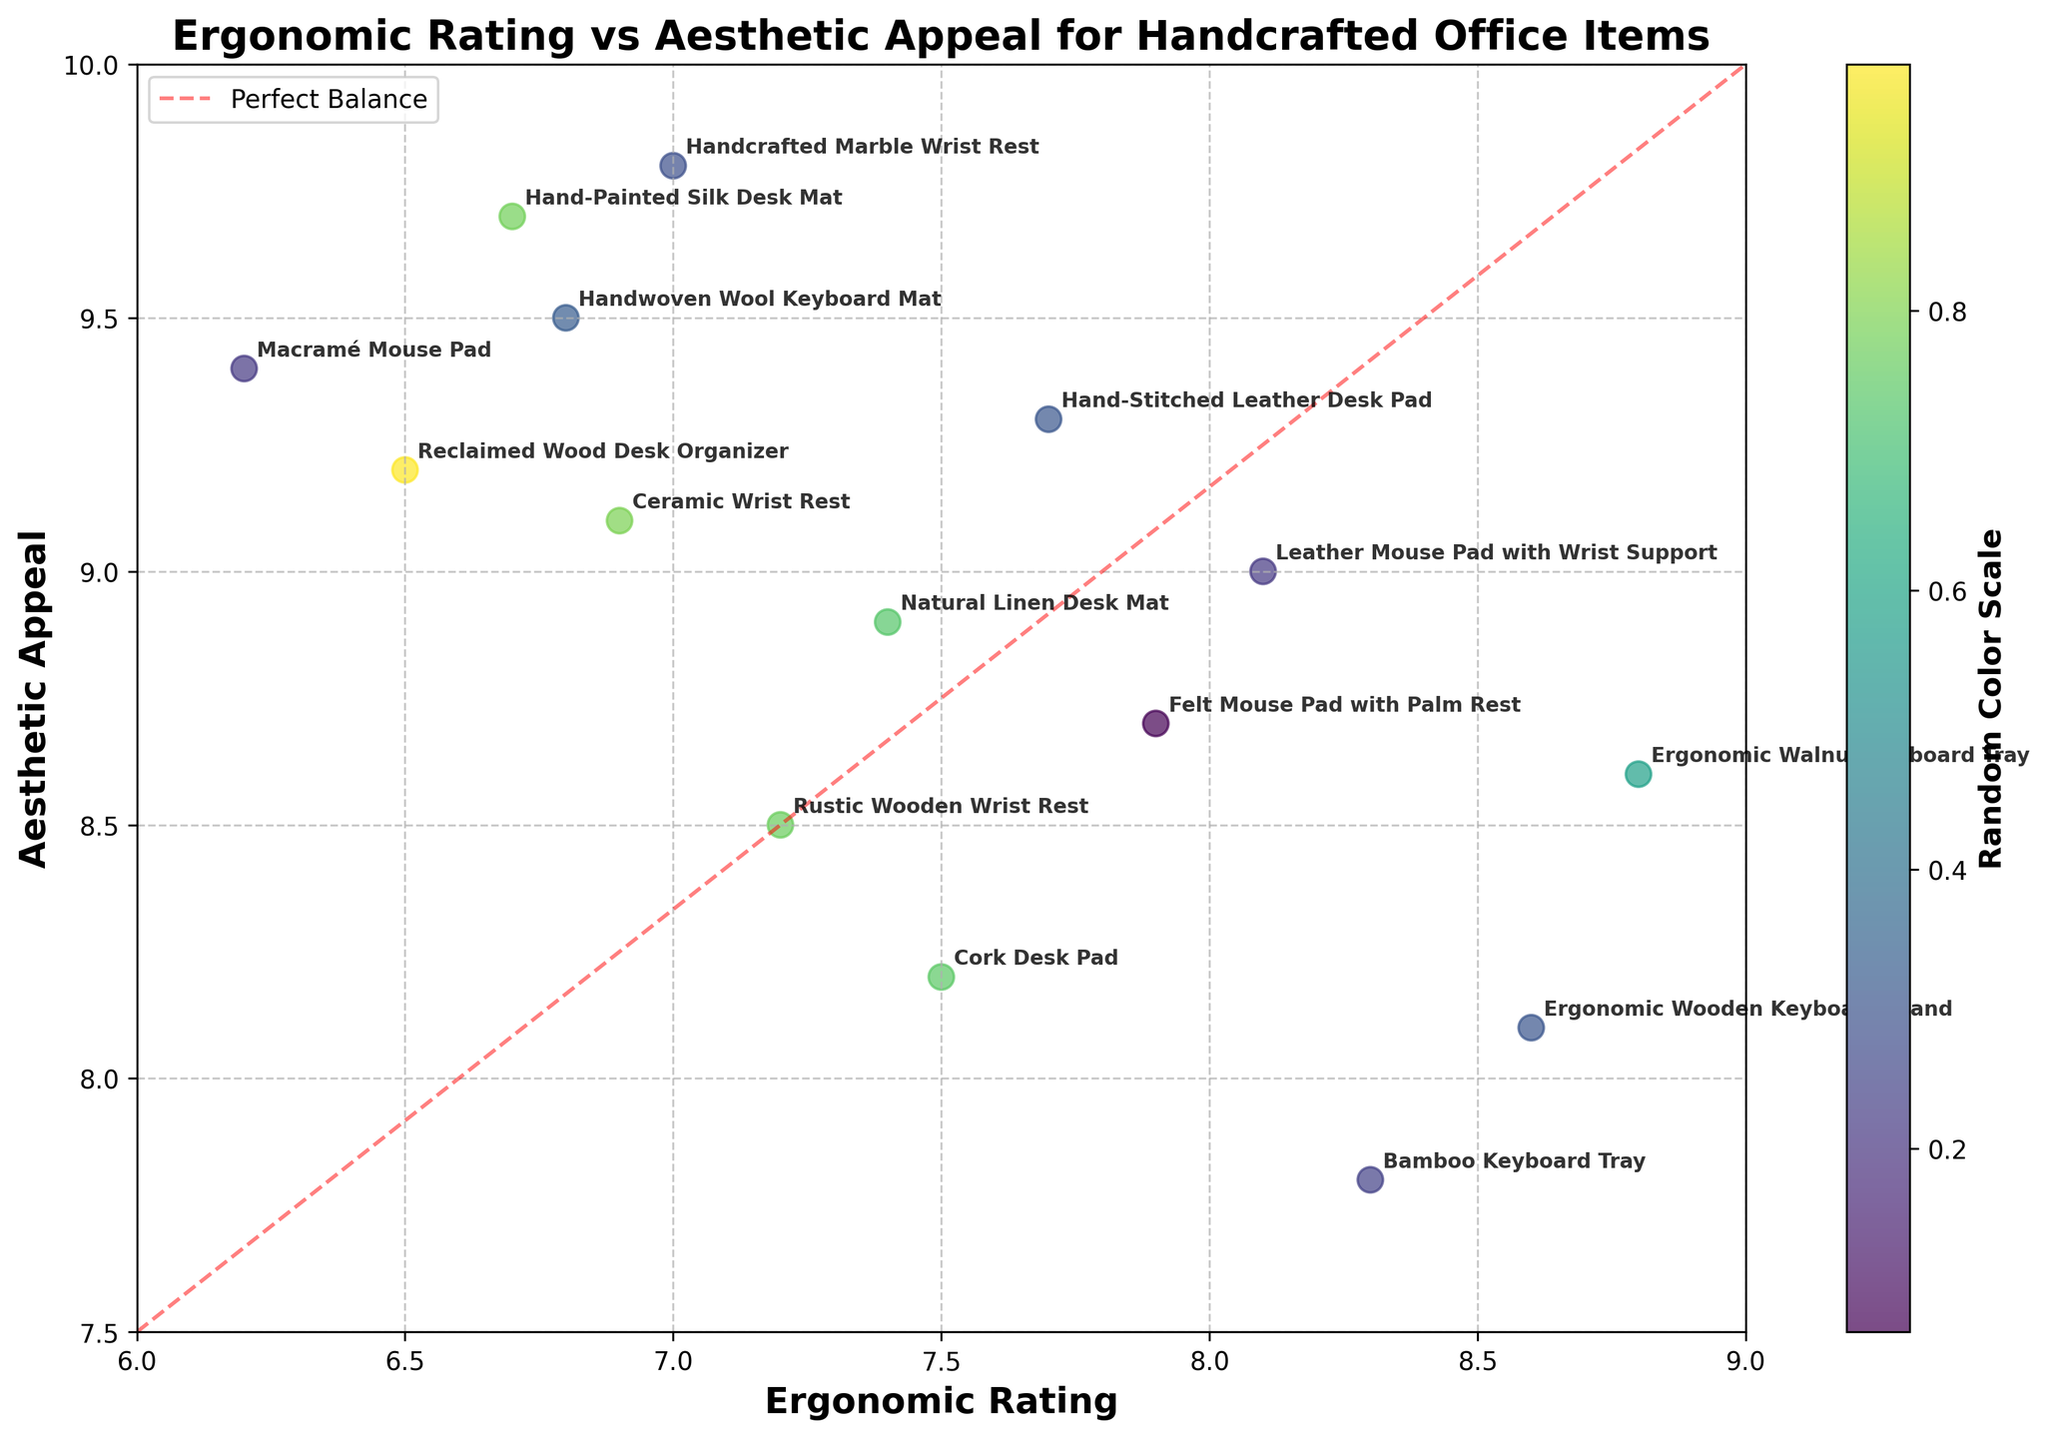How many items are plotted on the graph? Count the labels or points on the scatter plot to find the total number of products shown.
Answer: 15 What is the product with the highest ergonomic rating? Look for the point farthest to the right on the x-axis, which represents the ergonomic rating, and check its label.
Answer: Ergonomic Walnut Keyboard Tray Which product has the highest aesthetic appeal? Identify the point highest on the y-axis, representing aesthetic appeal, and check its label.
Answer: Handcrafted Marble Wrist Rest Which products are closest to the "Perfect Balance" diagonal line? Observe the annotated points near the red dashed line that represents equal ergonomic and aesthetic ratings.
Answer: Leather Mouse Pad with Wrist Support, Natural Linen Desk Mat What is the range of ergonomic ratings observed in the graph? Identify the smallest and largest values on the x-axis and subtract the smallest from the largest to calculate the range.
Answer: 6.2 to 8.8 Which product has a higher aesthetic appeal, the Hand-Painted Silk Desk Mat or the Macramé Mouse Pad? Compare the y-axis positions of the points labeled for Hand-Painted Silk Desk Mat and Macramé Mouse Pad to see which is higher.
Answer: Hand-Painted Silk Desk Mat Which product has both a moderate ergonomic rating and high aesthetic appeal, with ratings close to each other? Find a point where both ratings are near each other but where the aesthetic appeal is relatively high. This should be around middle values on the x-axis and high on the y-axis.
Answer: Reclaimed Wood Desk Organizer What is the average aesthetic appeal of the products with ergonomic ratings above 8.0? Identify the products with ergonomic ratings greater than 8.0 and calculate the average of their aesthetic appeal ratings.
Answer: (9.0 + 7.8 + 8.1 + 8.6) / 4 = 8.38 Which product would be considered an outlier in terms of having a low ergonomic rating but a high aesthetic appeal? Look for a point that is significantly lower on the x-axis but remains high on the y-axis, indicating a low ergonomic rating and high aesthetic appeal.
Answer: Macramé Mouse Pad Is the Hand-Stitched Leather Desk Pad more ergonomic or aesthetically appealing? Compare the x (ergonomic rating) and y (aesthetic appeal) values for the Hand-Stitched Leather Desk Pad to see which is higher.
Answer: Aesthetically appealing 